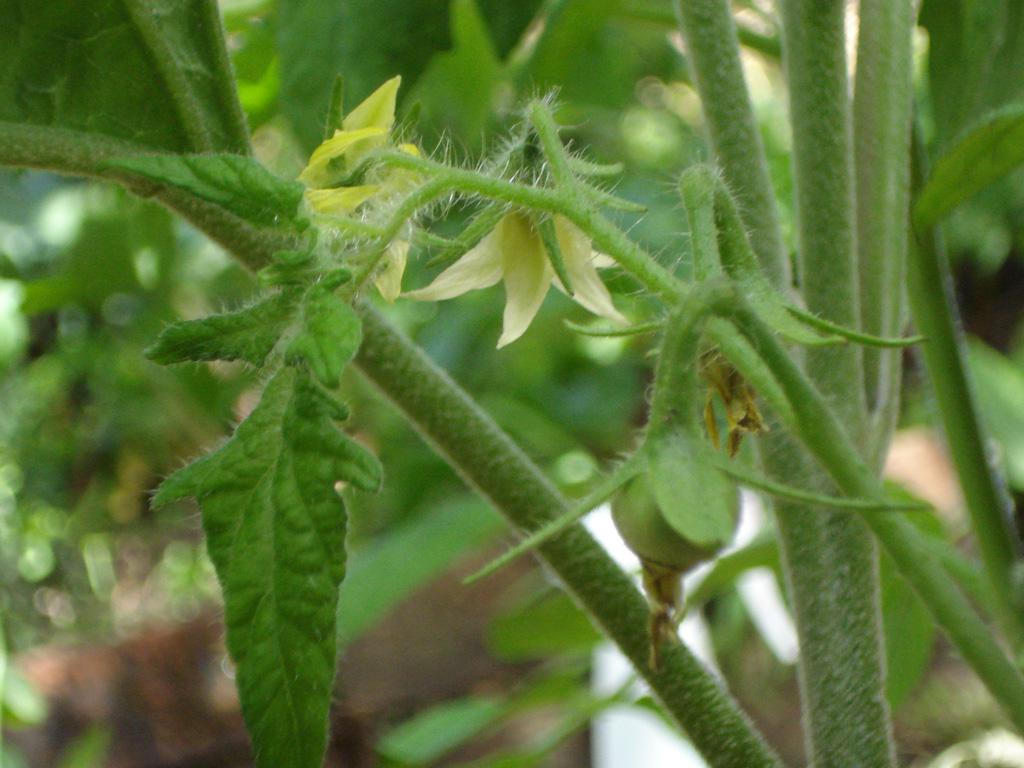What types of plants can be seen in the foreground of the image? There are two flowers and a vegetable on a plant in the foreground of the image. Can you describe the background of the image? The background of the image is blurred. What type of cheese can be seen in the aftermath of the event in the image? There is no cheese or event present in the image; it features two flowers and a vegetable on a plant in the foreground with a blurred background. 